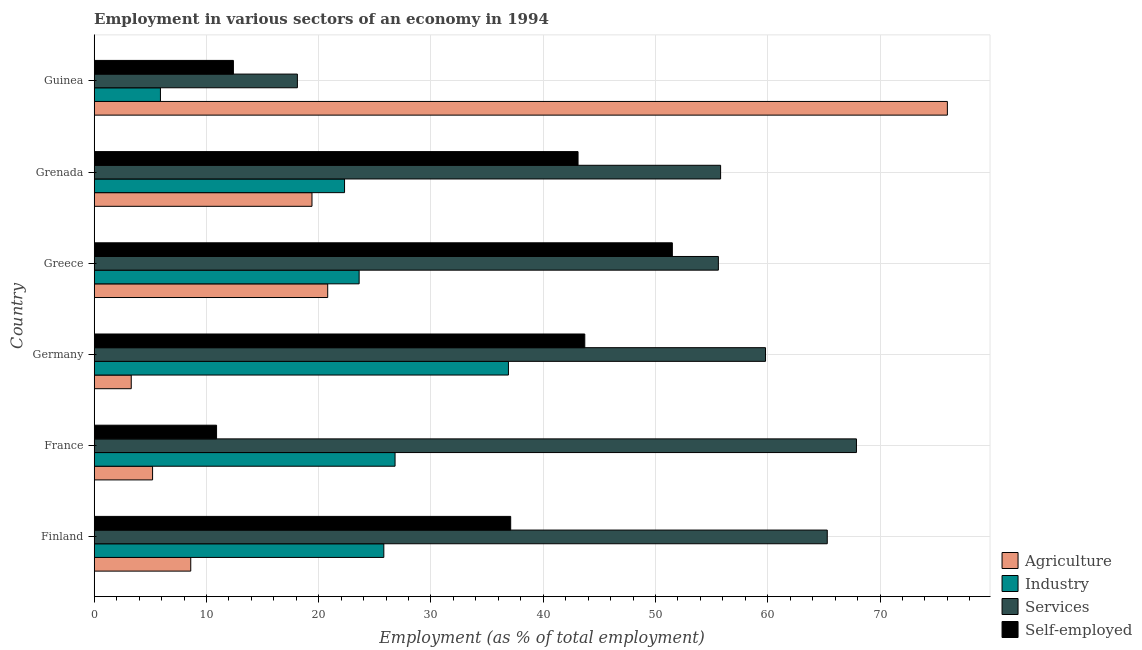How many different coloured bars are there?
Your response must be concise. 4. Are the number of bars per tick equal to the number of legend labels?
Provide a succinct answer. Yes. How many bars are there on the 1st tick from the top?
Keep it short and to the point. 4. What is the label of the 2nd group of bars from the top?
Your response must be concise. Grenada. What is the percentage of workers in agriculture in Greece?
Provide a short and direct response. 20.8. Across all countries, what is the maximum percentage of workers in services?
Make the answer very short. 67.9. Across all countries, what is the minimum percentage of workers in agriculture?
Provide a short and direct response. 3.3. In which country was the percentage of self employed workers minimum?
Provide a succinct answer. France. What is the total percentage of self employed workers in the graph?
Your response must be concise. 198.7. What is the difference between the percentage of self employed workers in Grenada and that in Guinea?
Keep it short and to the point. 30.7. What is the difference between the percentage of workers in industry in Finland and the percentage of self employed workers in France?
Offer a very short reply. 14.9. What is the average percentage of workers in services per country?
Provide a short and direct response. 53.75. What is the difference between the percentage of workers in agriculture and percentage of workers in industry in Finland?
Provide a succinct answer. -17.2. In how many countries, is the percentage of self employed workers greater than 28 %?
Offer a terse response. 4. What is the ratio of the percentage of workers in agriculture in Germany to that in Greece?
Provide a succinct answer. 0.16. What is the difference between the highest and the second highest percentage of self employed workers?
Your response must be concise. 7.8. What is the difference between the highest and the lowest percentage of workers in services?
Provide a succinct answer. 49.8. In how many countries, is the percentage of self employed workers greater than the average percentage of self employed workers taken over all countries?
Provide a short and direct response. 4. Is the sum of the percentage of workers in industry in Greece and Grenada greater than the maximum percentage of workers in agriculture across all countries?
Keep it short and to the point. No. What does the 2nd bar from the top in Finland represents?
Provide a short and direct response. Services. What does the 3rd bar from the bottom in France represents?
Your answer should be very brief. Services. Is it the case that in every country, the sum of the percentage of workers in agriculture and percentage of workers in industry is greater than the percentage of workers in services?
Give a very brief answer. No. Are all the bars in the graph horizontal?
Offer a terse response. Yes. How many countries are there in the graph?
Provide a succinct answer. 6. What is the difference between two consecutive major ticks on the X-axis?
Your answer should be very brief. 10. Where does the legend appear in the graph?
Keep it short and to the point. Bottom right. How are the legend labels stacked?
Your response must be concise. Vertical. What is the title of the graph?
Keep it short and to the point. Employment in various sectors of an economy in 1994. What is the label or title of the X-axis?
Make the answer very short. Employment (as % of total employment). What is the Employment (as % of total employment) of Agriculture in Finland?
Your answer should be very brief. 8.6. What is the Employment (as % of total employment) in Industry in Finland?
Your answer should be very brief. 25.8. What is the Employment (as % of total employment) in Services in Finland?
Offer a very short reply. 65.3. What is the Employment (as % of total employment) in Self-employed in Finland?
Offer a very short reply. 37.1. What is the Employment (as % of total employment) of Agriculture in France?
Offer a terse response. 5.2. What is the Employment (as % of total employment) in Industry in France?
Keep it short and to the point. 26.8. What is the Employment (as % of total employment) of Services in France?
Offer a very short reply. 67.9. What is the Employment (as % of total employment) in Self-employed in France?
Your answer should be very brief. 10.9. What is the Employment (as % of total employment) in Agriculture in Germany?
Provide a succinct answer. 3.3. What is the Employment (as % of total employment) of Industry in Germany?
Your response must be concise. 36.9. What is the Employment (as % of total employment) of Services in Germany?
Provide a succinct answer. 59.8. What is the Employment (as % of total employment) of Self-employed in Germany?
Ensure brevity in your answer.  43.7. What is the Employment (as % of total employment) in Agriculture in Greece?
Your answer should be very brief. 20.8. What is the Employment (as % of total employment) in Industry in Greece?
Provide a short and direct response. 23.6. What is the Employment (as % of total employment) in Services in Greece?
Your answer should be compact. 55.6. What is the Employment (as % of total employment) of Self-employed in Greece?
Offer a very short reply. 51.5. What is the Employment (as % of total employment) in Agriculture in Grenada?
Offer a terse response. 19.4. What is the Employment (as % of total employment) of Industry in Grenada?
Ensure brevity in your answer.  22.3. What is the Employment (as % of total employment) of Services in Grenada?
Your answer should be very brief. 55.8. What is the Employment (as % of total employment) in Self-employed in Grenada?
Offer a very short reply. 43.1. What is the Employment (as % of total employment) of Agriculture in Guinea?
Provide a succinct answer. 76. What is the Employment (as % of total employment) in Industry in Guinea?
Offer a very short reply. 5.9. What is the Employment (as % of total employment) of Services in Guinea?
Ensure brevity in your answer.  18.1. What is the Employment (as % of total employment) in Self-employed in Guinea?
Offer a very short reply. 12.4. Across all countries, what is the maximum Employment (as % of total employment) of Agriculture?
Keep it short and to the point. 76. Across all countries, what is the maximum Employment (as % of total employment) in Industry?
Ensure brevity in your answer.  36.9. Across all countries, what is the maximum Employment (as % of total employment) in Services?
Provide a succinct answer. 67.9. Across all countries, what is the maximum Employment (as % of total employment) in Self-employed?
Give a very brief answer. 51.5. Across all countries, what is the minimum Employment (as % of total employment) in Agriculture?
Give a very brief answer. 3.3. Across all countries, what is the minimum Employment (as % of total employment) of Industry?
Ensure brevity in your answer.  5.9. Across all countries, what is the minimum Employment (as % of total employment) of Services?
Provide a short and direct response. 18.1. Across all countries, what is the minimum Employment (as % of total employment) in Self-employed?
Your answer should be very brief. 10.9. What is the total Employment (as % of total employment) of Agriculture in the graph?
Your answer should be very brief. 133.3. What is the total Employment (as % of total employment) of Industry in the graph?
Make the answer very short. 141.3. What is the total Employment (as % of total employment) of Services in the graph?
Provide a succinct answer. 322.5. What is the total Employment (as % of total employment) in Self-employed in the graph?
Your answer should be compact. 198.7. What is the difference between the Employment (as % of total employment) of Services in Finland and that in France?
Offer a terse response. -2.6. What is the difference between the Employment (as % of total employment) in Self-employed in Finland and that in France?
Provide a short and direct response. 26.2. What is the difference between the Employment (as % of total employment) in Industry in Finland and that in Germany?
Keep it short and to the point. -11.1. What is the difference between the Employment (as % of total employment) in Agriculture in Finland and that in Greece?
Your response must be concise. -12.2. What is the difference between the Employment (as % of total employment) of Self-employed in Finland and that in Greece?
Your answer should be compact. -14.4. What is the difference between the Employment (as % of total employment) in Industry in Finland and that in Grenada?
Your answer should be very brief. 3.5. What is the difference between the Employment (as % of total employment) of Services in Finland and that in Grenada?
Make the answer very short. 9.5. What is the difference between the Employment (as % of total employment) in Self-employed in Finland and that in Grenada?
Ensure brevity in your answer.  -6. What is the difference between the Employment (as % of total employment) of Agriculture in Finland and that in Guinea?
Provide a succinct answer. -67.4. What is the difference between the Employment (as % of total employment) of Industry in Finland and that in Guinea?
Offer a very short reply. 19.9. What is the difference between the Employment (as % of total employment) in Services in Finland and that in Guinea?
Give a very brief answer. 47.2. What is the difference between the Employment (as % of total employment) in Self-employed in Finland and that in Guinea?
Make the answer very short. 24.7. What is the difference between the Employment (as % of total employment) of Agriculture in France and that in Germany?
Ensure brevity in your answer.  1.9. What is the difference between the Employment (as % of total employment) of Industry in France and that in Germany?
Offer a terse response. -10.1. What is the difference between the Employment (as % of total employment) in Self-employed in France and that in Germany?
Make the answer very short. -32.8. What is the difference between the Employment (as % of total employment) of Agriculture in France and that in Greece?
Make the answer very short. -15.6. What is the difference between the Employment (as % of total employment) of Services in France and that in Greece?
Offer a terse response. 12.3. What is the difference between the Employment (as % of total employment) in Self-employed in France and that in Greece?
Your answer should be compact. -40.6. What is the difference between the Employment (as % of total employment) of Agriculture in France and that in Grenada?
Make the answer very short. -14.2. What is the difference between the Employment (as % of total employment) of Industry in France and that in Grenada?
Ensure brevity in your answer.  4.5. What is the difference between the Employment (as % of total employment) in Services in France and that in Grenada?
Your answer should be compact. 12.1. What is the difference between the Employment (as % of total employment) in Self-employed in France and that in Grenada?
Your response must be concise. -32.2. What is the difference between the Employment (as % of total employment) of Agriculture in France and that in Guinea?
Provide a short and direct response. -70.8. What is the difference between the Employment (as % of total employment) of Industry in France and that in Guinea?
Keep it short and to the point. 20.9. What is the difference between the Employment (as % of total employment) of Services in France and that in Guinea?
Provide a succinct answer. 49.8. What is the difference between the Employment (as % of total employment) in Self-employed in France and that in Guinea?
Give a very brief answer. -1.5. What is the difference between the Employment (as % of total employment) of Agriculture in Germany and that in Greece?
Provide a succinct answer. -17.5. What is the difference between the Employment (as % of total employment) of Services in Germany and that in Greece?
Offer a terse response. 4.2. What is the difference between the Employment (as % of total employment) of Self-employed in Germany and that in Greece?
Give a very brief answer. -7.8. What is the difference between the Employment (as % of total employment) of Agriculture in Germany and that in Grenada?
Your response must be concise. -16.1. What is the difference between the Employment (as % of total employment) of Services in Germany and that in Grenada?
Your response must be concise. 4. What is the difference between the Employment (as % of total employment) in Agriculture in Germany and that in Guinea?
Provide a short and direct response. -72.7. What is the difference between the Employment (as % of total employment) of Industry in Germany and that in Guinea?
Your response must be concise. 31. What is the difference between the Employment (as % of total employment) in Services in Germany and that in Guinea?
Make the answer very short. 41.7. What is the difference between the Employment (as % of total employment) in Self-employed in Germany and that in Guinea?
Ensure brevity in your answer.  31.3. What is the difference between the Employment (as % of total employment) of Industry in Greece and that in Grenada?
Your response must be concise. 1.3. What is the difference between the Employment (as % of total employment) in Agriculture in Greece and that in Guinea?
Offer a very short reply. -55.2. What is the difference between the Employment (as % of total employment) in Industry in Greece and that in Guinea?
Provide a succinct answer. 17.7. What is the difference between the Employment (as % of total employment) in Services in Greece and that in Guinea?
Offer a very short reply. 37.5. What is the difference between the Employment (as % of total employment) of Self-employed in Greece and that in Guinea?
Offer a very short reply. 39.1. What is the difference between the Employment (as % of total employment) of Agriculture in Grenada and that in Guinea?
Keep it short and to the point. -56.6. What is the difference between the Employment (as % of total employment) of Services in Grenada and that in Guinea?
Give a very brief answer. 37.7. What is the difference between the Employment (as % of total employment) in Self-employed in Grenada and that in Guinea?
Provide a short and direct response. 30.7. What is the difference between the Employment (as % of total employment) in Agriculture in Finland and the Employment (as % of total employment) in Industry in France?
Provide a succinct answer. -18.2. What is the difference between the Employment (as % of total employment) of Agriculture in Finland and the Employment (as % of total employment) of Services in France?
Offer a very short reply. -59.3. What is the difference between the Employment (as % of total employment) of Agriculture in Finland and the Employment (as % of total employment) of Self-employed in France?
Your response must be concise. -2.3. What is the difference between the Employment (as % of total employment) in Industry in Finland and the Employment (as % of total employment) in Services in France?
Provide a succinct answer. -42.1. What is the difference between the Employment (as % of total employment) in Industry in Finland and the Employment (as % of total employment) in Self-employed in France?
Provide a succinct answer. 14.9. What is the difference between the Employment (as % of total employment) in Services in Finland and the Employment (as % of total employment) in Self-employed in France?
Offer a very short reply. 54.4. What is the difference between the Employment (as % of total employment) of Agriculture in Finland and the Employment (as % of total employment) of Industry in Germany?
Make the answer very short. -28.3. What is the difference between the Employment (as % of total employment) of Agriculture in Finland and the Employment (as % of total employment) of Services in Germany?
Offer a very short reply. -51.2. What is the difference between the Employment (as % of total employment) of Agriculture in Finland and the Employment (as % of total employment) of Self-employed in Germany?
Your response must be concise. -35.1. What is the difference between the Employment (as % of total employment) in Industry in Finland and the Employment (as % of total employment) in Services in Germany?
Give a very brief answer. -34. What is the difference between the Employment (as % of total employment) in Industry in Finland and the Employment (as % of total employment) in Self-employed in Germany?
Provide a succinct answer. -17.9. What is the difference between the Employment (as % of total employment) in Services in Finland and the Employment (as % of total employment) in Self-employed in Germany?
Make the answer very short. 21.6. What is the difference between the Employment (as % of total employment) in Agriculture in Finland and the Employment (as % of total employment) in Services in Greece?
Offer a very short reply. -47. What is the difference between the Employment (as % of total employment) of Agriculture in Finland and the Employment (as % of total employment) of Self-employed in Greece?
Offer a very short reply. -42.9. What is the difference between the Employment (as % of total employment) of Industry in Finland and the Employment (as % of total employment) of Services in Greece?
Provide a short and direct response. -29.8. What is the difference between the Employment (as % of total employment) of Industry in Finland and the Employment (as % of total employment) of Self-employed in Greece?
Offer a terse response. -25.7. What is the difference between the Employment (as % of total employment) of Agriculture in Finland and the Employment (as % of total employment) of Industry in Grenada?
Keep it short and to the point. -13.7. What is the difference between the Employment (as % of total employment) in Agriculture in Finland and the Employment (as % of total employment) in Services in Grenada?
Give a very brief answer. -47.2. What is the difference between the Employment (as % of total employment) in Agriculture in Finland and the Employment (as % of total employment) in Self-employed in Grenada?
Ensure brevity in your answer.  -34.5. What is the difference between the Employment (as % of total employment) of Industry in Finland and the Employment (as % of total employment) of Self-employed in Grenada?
Provide a short and direct response. -17.3. What is the difference between the Employment (as % of total employment) of Agriculture in Finland and the Employment (as % of total employment) of Industry in Guinea?
Keep it short and to the point. 2.7. What is the difference between the Employment (as % of total employment) in Agriculture in Finland and the Employment (as % of total employment) in Self-employed in Guinea?
Offer a terse response. -3.8. What is the difference between the Employment (as % of total employment) of Industry in Finland and the Employment (as % of total employment) of Services in Guinea?
Keep it short and to the point. 7.7. What is the difference between the Employment (as % of total employment) in Services in Finland and the Employment (as % of total employment) in Self-employed in Guinea?
Your answer should be compact. 52.9. What is the difference between the Employment (as % of total employment) in Agriculture in France and the Employment (as % of total employment) in Industry in Germany?
Make the answer very short. -31.7. What is the difference between the Employment (as % of total employment) in Agriculture in France and the Employment (as % of total employment) in Services in Germany?
Give a very brief answer. -54.6. What is the difference between the Employment (as % of total employment) of Agriculture in France and the Employment (as % of total employment) of Self-employed in Germany?
Your answer should be compact. -38.5. What is the difference between the Employment (as % of total employment) in Industry in France and the Employment (as % of total employment) in Services in Germany?
Your answer should be very brief. -33. What is the difference between the Employment (as % of total employment) in Industry in France and the Employment (as % of total employment) in Self-employed in Germany?
Give a very brief answer. -16.9. What is the difference between the Employment (as % of total employment) of Services in France and the Employment (as % of total employment) of Self-employed in Germany?
Provide a short and direct response. 24.2. What is the difference between the Employment (as % of total employment) of Agriculture in France and the Employment (as % of total employment) of Industry in Greece?
Provide a short and direct response. -18.4. What is the difference between the Employment (as % of total employment) in Agriculture in France and the Employment (as % of total employment) in Services in Greece?
Provide a succinct answer. -50.4. What is the difference between the Employment (as % of total employment) of Agriculture in France and the Employment (as % of total employment) of Self-employed in Greece?
Offer a terse response. -46.3. What is the difference between the Employment (as % of total employment) in Industry in France and the Employment (as % of total employment) in Services in Greece?
Provide a short and direct response. -28.8. What is the difference between the Employment (as % of total employment) in Industry in France and the Employment (as % of total employment) in Self-employed in Greece?
Ensure brevity in your answer.  -24.7. What is the difference between the Employment (as % of total employment) in Services in France and the Employment (as % of total employment) in Self-employed in Greece?
Your answer should be very brief. 16.4. What is the difference between the Employment (as % of total employment) of Agriculture in France and the Employment (as % of total employment) of Industry in Grenada?
Provide a succinct answer. -17.1. What is the difference between the Employment (as % of total employment) of Agriculture in France and the Employment (as % of total employment) of Services in Grenada?
Your answer should be compact. -50.6. What is the difference between the Employment (as % of total employment) of Agriculture in France and the Employment (as % of total employment) of Self-employed in Grenada?
Make the answer very short. -37.9. What is the difference between the Employment (as % of total employment) in Industry in France and the Employment (as % of total employment) in Self-employed in Grenada?
Your response must be concise. -16.3. What is the difference between the Employment (as % of total employment) in Services in France and the Employment (as % of total employment) in Self-employed in Grenada?
Your response must be concise. 24.8. What is the difference between the Employment (as % of total employment) of Agriculture in France and the Employment (as % of total employment) of Industry in Guinea?
Give a very brief answer. -0.7. What is the difference between the Employment (as % of total employment) in Agriculture in France and the Employment (as % of total employment) in Services in Guinea?
Offer a very short reply. -12.9. What is the difference between the Employment (as % of total employment) of Industry in France and the Employment (as % of total employment) of Services in Guinea?
Your answer should be very brief. 8.7. What is the difference between the Employment (as % of total employment) in Industry in France and the Employment (as % of total employment) in Self-employed in Guinea?
Ensure brevity in your answer.  14.4. What is the difference between the Employment (as % of total employment) of Services in France and the Employment (as % of total employment) of Self-employed in Guinea?
Your response must be concise. 55.5. What is the difference between the Employment (as % of total employment) of Agriculture in Germany and the Employment (as % of total employment) of Industry in Greece?
Keep it short and to the point. -20.3. What is the difference between the Employment (as % of total employment) in Agriculture in Germany and the Employment (as % of total employment) in Services in Greece?
Your response must be concise. -52.3. What is the difference between the Employment (as % of total employment) of Agriculture in Germany and the Employment (as % of total employment) of Self-employed in Greece?
Your response must be concise. -48.2. What is the difference between the Employment (as % of total employment) in Industry in Germany and the Employment (as % of total employment) in Services in Greece?
Provide a short and direct response. -18.7. What is the difference between the Employment (as % of total employment) of Industry in Germany and the Employment (as % of total employment) of Self-employed in Greece?
Offer a terse response. -14.6. What is the difference between the Employment (as % of total employment) in Agriculture in Germany and the Employment (as % of total employment) in Industry in Grenada?
Provide a short and direct response. -19. What is the difference between the Employment (as % of total employment) in Agriculture in Germany and the Employment (as % of total employment) in Services in Grenada?
Provide a succinct answer. -52.5. What is the difference between the Employment (as % of total employment) of Agriculture in Germany and the Employment (as % of total employment) of Self-employed in Grenada?
Ensure brevity in your answer.  -39.8. What is the difference between the Employment (as % of total employment) in Industry in Germany and the Employment (as % of total employment) in Services in Grenada?
Offer a very short reply. -18.9. What is the difference between the Employment (as % of total employment) in Services in Germany and the Employment (as % of total employment) in Self-employed in Grenada?
Your answer should be compact. 16.7. What is the difference between the Employment (as % of total employment) of Agriculture in Germany and the Employment (as % of total employment) of Industry in Guinea?
Offer a very short reply. -2.6. What is the difference between the Employment (as % of total employment) in Agriculture in Germany and the Employment (as % of total employment) in Services in Guinea?
Your response must be concise. -14.8. What is the difference between the Employment (as % of total employment) of Industry in Germany and the Employment (as % of total employment) of Self-employed in Guinea?
Your response must be concise. 24.5. What is the difference between the Employment (as % of total employment) of Services in Germany and the Employment (as % of total employment) of Self-employed in Guinea?
Provide a succinct answer. 47.4. What is the difference between the Employment (as % of total employment) in Agriculture in Greece and the Employment (as % of total employment) in Industry in Grenada?
Provide a short and direct response. -1.5. What is the difference between the Employment (as % of total employment) of Agriculture in Greece and the Employment (as % of total employment) of Services in Grenada?
Provide a short and direct response. -35. What is the difference between the Employment (as % of total employment) in Agriculture in Greece and the Employment (as % of total employment) in Self-employed in Grenada?
Provide a short and direct response. -22.3. What is the difference between the Employment (as % of total employment) in Industry in Greece and the Employment (as % of total employment) in Services in Grenada?
Your answer should be very brief. -32.2. What is the difference between the Employment (as % of total employment) in Industry in Greece and the Employment (as % of total employment) in Self-employed in Grenada?
Keep it short and to the point. -19.5. What is the difference between the Employment (as % of total employment) of Services in Greece and the Employment (as % of total employment) of Self-employed in Grenada?
Your answer should be very brief. 12.5. What is the difference between the Employment (as % of total employment) of Services in Greece and the Employment (as % of total employment) of Self-employed in Guinea?
Give a very brief answer. 43.2. What is the difference between the Employment (as % of total employment) in Agriculture in Grenada and the Employment (as % of total employment) in Industry in Guinea?
Keep it short and to the point. 13.5. What is the difference between the Employment (as % of total employment) in Agriculture in Grenada and the Employment (as % of total employment) in Services in Guinea?
Give a very brief answer. 1.3. What is the difference between the Employment (as % of total employment) of Agriculture in Grenada and the Employment (as % of total employment) of Self-employed in Guinea?
Provide a short and direct response. 7. What is the difference between the Employment (as % of total employment) of Services in Grenada and the Employment (as % of total employment) of Self-employed in Guinea?
Provide a succinct answer. 43.4. What is the average Employment (as % of total employment) of Agriculture per country?
Make the answer very short. 22.22. What is the average Employment (as % of total employment) in Industry per country?
Give a very brief answer. 23.55. What is the average Employment (as % of total employment) in Services per country?
Your answer should be compact. 53.75. What is the average Employment (as % of total employment) of Self-employed per country?
Give a very brief answer. 33.12. What is the difference between the Employment (as % of total employment) of Agriculture and Employment (as % of total employment) of Industry in Finland?
Ensure brevity in your answer.  -17.2. What is the difference between the Employment (as % of total employment) of Agriculture and Employment (as % of total employment) of Services in Finland?
Your response must be concise. -56.7. What is the difference between the Employment (as % of total employment) of Agriculture and Employment (as % of total employment) of Self-employed in Finland?
Keep it short and to the point. -28.5. What is the difference between the Employment (as % of total employment) of Industry and Employment (as % of total employment) of Services in Finland?
Your answer should be compact. -39.5. What is the difference between the Employment (as % of total employment) in Services and Employment (as % of total employment) in Self-employed in Finland?
Offer a very short reply. 28.2. What is the difference between the Employment (as % of total employment) of Agriculture and Employment (as % of total employment) of Industry in France?
Offer a very short reply. -21.6. What is the difference between the Employment (as % of total employment) in Agriculture and Employment (as % of total employment) in Services in France?
Keep it short and to the point. -62.7. What is the difference between the Employment (as % of total employment) of Agriculture and Employment (as % of total employment) of Self-employed in France?
Your answer should be compact. -5.7. What is the difference between the Employment (as % of total employment) in Industry and Employment (as % of total employment) in Services in France?
Keep it short and to the point. -41.1. What is the difference between the Employment (as % of total employment) of Agriculture and Employment (as % of total employment) of Industry in Germany?
Provide a short and direct response. -33.6. What is the difference between the Employment (as % of total employment) of Agriculture and Employment (as % of total employment) of Services in Germany?
Make the answer very short. -56.5. What is the difference between the Employment (as % of total employment) of Agriculture and Employment (as % of total employment) of Self-employed in Germany?
Give a very brief answer. -40.4. What is the difference between the Employment (as % of total employment) in Industry and Employment (as % of total employment) in Services in Germany?
Make the answer very short. -22.9. What is the difference between the Employment (as % of total employment) in Industry and Employment (as % of total employment) in Self-employed in Germany?
Your response must be concise. -6.8. What is the difference between the Employment (as % of total employment) in Agriculture and Employment (as % of total employment) in Services in Greece?
Make the answer very short. -34.8. What is the difference between the Employment (as % of total employment) of Agriculture and Employment (as % of total employment) of Self-employed in Greece?
Give a very brief answer. -30.7. What is the difference between the Employment (as % of total employment) of Industry and Employment (as % of total employment) of Services in Greece?
Your answer should be compact. -32. What is the difference between the Employment (as % of total employment) of Industry and Employment (as % of total employment) of Self-employed in Greece?
Give a very brief answer. -27.9. What is the difference between the Employment (as % of total employment) in Services and Employment (as % of total employment) in Self-employed in Greece?
Offer a terse response. 4.1. What is the difference between the Employment (as % of total employment) of Agriculture and Employment (as % of total employment) of Services in Grenada?
Offer a very short reply. -36.4. What is the difference between the Employment (as % of total employment) in Agriculture and Employment (as % of total employment) in Self-employed in Grenada?
Offer a very short reply. -23.7. What is the difference between the Employment (as % of total employment) of Industry and Employment (as % of total employment) of Services in Grenada?
Make the answer very short. -33.5. What is the difference between the Employment (as % of total employment) of Industry and Employment (as % of total employment) of Self-employed in Grenada?
Provide a succinct answer. -20.8. What is the difference between the Employment (as % of total employment) of Agriculture and Employment (as % of total employment) of Industry in Guinea?
Provide a succinct answer. 70.1. What is the difference between the Employment (as % of total employment) in Agriculture and Employment (as % of total employment) in Services in Guinea?
Provide a succinct answer. 57.9. What is the difference between the Employment (as % of total employment) in Agriculture and Employment (as % of total employment) in Self-employed in Guinea?
Keep it short and to the point. 63.6. What is the difference between the Employment (as % of total employment) of Industry and Employment (as % of total employment) of Services in Guinea?
Ensure brevity in your answer.  -12.2. What is the difference between the Employment (as % of total employment) of Industry and Employment (as % of total employment) of Self-employed in Guinea?
Offer a very short reply. -6.5. What is the ratio of the Employment (as % of total employment) in Agriculture in Finland to that in France?
Keep it short and to the point. 1.65. What is the ratio of the Employment (as % of total employment) of Industry in Finland to that in France?
Your answer should be very brief. 0.96. What is the ratio of the Employment (as % of total employment) in Services in Finland to that in France?
Your answer should be compact. 0.96. What is the ratio of the Employment (as % of total employment) in Self-employed in Finland to that in France?
Offer a terse response. 3.4. What is the ratio of the Employment (as % of total employment) in Agriculture in Finland to that in Germany?
Make the answer very short. 2.61. What is the ratio of the Employment (as % of total employment) of Industry in Finland to that in Germany?
Give a very brief answer. 0.7. What is the ratio of the Employment (as % of total employment) of Services in Finland to that in Germany?
Your answer should be compact. 1.09. What is the ratio of the Employment (as % of total employment) in Self-employed in Finland to that in Germany?
Provide a short and direct response. 0.85. What is the ratio of the Employment (as % of total employment) in Agriculture in Finland to that in Greece?
Give a very brief answer. 0.41. What is the ratio of the Employment (as % of total employment) in Industry in Finland to that in Greece?
Keep it short and to the point. 1.09. What is the ratio of the Employment (as % of total employment) of Services in Finland to that in Greece?
Offer a very short reply. 1.17. What is the ratio of the Employment (as % of total employment) of Self-employed in Finland to that in Greece?
Your response must be concise. 0.72. What is the ratio of the Employment (as % of total employment) in Agriculture in Finland to that in Grenada?
Offer a very short reply. 0.44. What is the ratio of the Employment (as % of total employment) in Industry in Finland to that in Grenada?
Your response must be concise. 1.16. What is the ratio of the Employment (as % of total employment) of Services in Finland to that in Grenada?
Ensure brevity in your answer.  1.17. What is the ratio of the Employment (as % of total employment) in Self-employed in Finland to that in Grenada?
Provide a short and direct response. 0.86. What is the ratio of the Employment (as % of total employment) in Agriculture in Finland to that in Guinea?
Your answer should be compact. 0.11. What is the ratio of the Employment (as % of total employment) in Industry in Finland to that in Guinea?
Provide a short and direct response. 4.37. What is the ratio of the Employment (as % of total employment) of Services in Finland to that in Guinea?
Ensure brevity in your answer.  3.61. What is the ratio of the Employment (as % of total employment) of Self-employed in Finland to that in Guinea?
Keep it short and to the point. 2.99. What is the ratio of the Employment (as % of total employment) in Agriculture in France to that in Germany?
Make the answer very short. 1.58. What is the ratio of the Employment (as % of total employment) in Industry in France to that in Germany?
Offer a very short reply. 0.73. What is the ratio of the Employment (as % of total employment) of Services in France to that in Germany?
Offer a very short reply. 1.14. What is the ratio of the Employment (as % of total employment) in Self-employed in France to that in Germany?
Provide a short and direct response. 0.25. What is the ratio of the Employment (as % of total employment) in Industry in France to that in Greece?
Give a very brief answer. 1.14. What is the ratio of the Employment (as % of total employment) in Services in France to that in Greece?
Your response must be concise. 1.22. What is the ratio of the Employment (as % of total employment) in Self-employed in France to that in Greece?
Make the answer very short. 0.21. What is the ratio of the Employment (as % of total employment) of Agriculture in France to that in Grenada?
Keep it short and to the point. 0.27. What is the ratio of the Employment (as % of total employment) in Industry in France to that in Grenada?
Offer a very short reply. 1.2. What is the ratio of the Employment (as % of total employment) in Services in France to that in Grenada?
Your answer should be compact. 1.22. What is the ratio of the Employment (as % of total employment) in Self-employed in France to that in Grenada?
Your answer should be very brief. 0.25. What is the ratio of the Employment (as % of total employment) in Agriculture in France to that in Guinea?
Keep it short and to the point. 0.07. What is the ratio of the Employment (as % of total employment) in Industry in France to that in Guinea?
Give a very brief answer. 4.54. What is the ratio of the Employment (as % of total employment) of Services in France to that in Guinea?
Your answer should be very brief. 3.75. What is the ratio of the Employment (as % of total employment) in Self-employed in France to that in Guinea?
Provide a succinct answer. 0.88. What is the ratio of the Employment (as % of total employment) in Agriculture in Germany to that in Greece?
Provide a succinct answer. 0.16. What is the ratio of the Employment (as % of total employment) in Industry in Germany to that in Greece?
Your answer should be compact. 1.56. What is the ratio of the Employment (as % of total employment) in Services in Germany to that in Greece?
Provide a short and direct response. 1.08. What is the ratio of the Employment (as % of total employment) of Self-employed in Germany to that in Greece?
Your answer should be very brief. 0.85. What is the ratio of the Employment (as % of total employment) in Agriculture in Germany to that in Grenada?
Give a very brief answer. 0.17. What is the ratio of the Employment (as % of total employment) of Industry in Germany to that in Grenada?
Your answer should be compact. 1.65. What is the ratio of the Employment (as % of total employment) in Services in Germany to that in Grenada?
Give a very brief answer. 1.07. What is the ratio of the Employment (as % of total employment) of Self-employed in Germany to that in Grenada?
Provide a succinct answer. 1.01. What is the ratio of the Employment (as % of total employment) in Agriculture in Germany to that in Guinea?
Provide a short and direct response. 0.04. What is the ratio of the Employment (as % of total employment) of Industry in Germany to that in Guinea?
Ensure brevity in your answer.  6.25. What is the ratio of the Employment (as % of total employment) of Services in Germany to that in Guinea?
Ensure brevity in your answer.  3.3. What is the ratio of the Employment (as % of total employment) of Self-employed in Germany to that in Guinea?
Ensure brevity in your answer.  3.52. What is the ratio of the Employment (as % of total employment) of Agriculture in Greece to that in Grenada?
Your response must be concise. 1.07. What is the ratio of the Employment (as % of total employment) in Industry in Greece to that in Grenada?
Offer a terse response. 1.06. What is the ratio of the Employment (as % of total employment) in Self-employed in Greece to that in Grenada?
Your answer should be compact. 1.19. What is the ratio of the Employment (as % of total employment) of Agriculture in Greece to that in Guinea?
Offer a terse response. 0.27. What is the ratio of the Employment (as % of total employment) in Industry in Greece to that in Guinea?
Provide a succinct answer. 4. What is the ratio of the Employment (as % of total employment) of Services in Greece to that in Guinea?
Give a very brief answer. 3.07. What is the ratio of the Employment (as % of total employment) in Self-employed in Greece to that in Guinea?
Your response must be concise. 4.15. What is the ratio of the Employment (as % of total employment) in Agriculture in Grenada to that in Guinea?
Keep it short and to the point. 0.26. What is the ratio of the Employment (as % of total employment) in Industry in Grenada to that in Guinea?
Provide a succinct answer. 3.78. What is the ratio of the Employment (as % of total employment) in Services in Grenada to that in Guinea?
Your answer should be compact. 3.08. What is the ratio of the Employment (as % of total employment) in Self-employed in Grenada to that in Guinea?
Offer a very short reply. 3.48. What is the difference between the highest and the second highest Employment (as % of total employment) in Agriculture?
Your answer should be compact. 55.2. What is the difference between the highest and the second highest Employment (as % of total employment) of Services?
Give a very brief answer. 2.6. What is the difference between the highest and the second highest Employment (as % of total employment) in Self-employed?
Provide a short and direct response. 7.8. What is the difference between the highest and the lowest Employment (as % of total employment) in Agriculture?
Ensure brevity in your answer.  72.7. What is the difference between the highest and the lowest Employment (as % of total employment) in Services?
Make the answer very short. 49.8. What is the difference between the highest and the lowest Employment (as % of total employment) in Self-employed?
Provide a short and direct response. 40.6. 